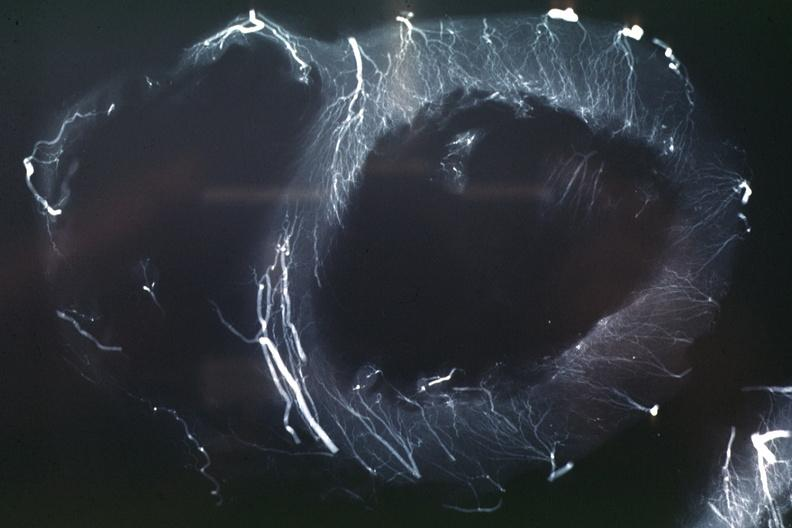s angiogram present?
Answer the question using a single word or phrase. Yes 